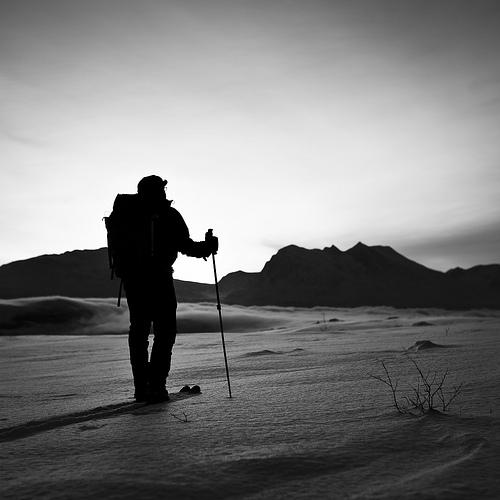Question: where is pack?
Choices:
A. On the floor.
B. On the table.
C. On the person's back.
D. On the door.
Answer with the letter. Answer: C Question: what is on person's head?
Choices:
A. Hat.
B. A head band.
C. A flower.
D. A crown.
Answer with the letter. Answer: A Question: where is weed?
Choices:
A. On upper left.
B. On upper right.
C. On lower left.
D. On lower right.
Answer with the letter. Answer: D Question: what is in background?
Choices:
A. A river.
B. A volcano.
C. An ocean.
D. Mountains.
Answer with the letter. Answer: D Question: what kind of photo?
Choices:
A. Color.
B. Digital.
C. Film.
D. Black and white.
Answer with the letter. Answer: D 